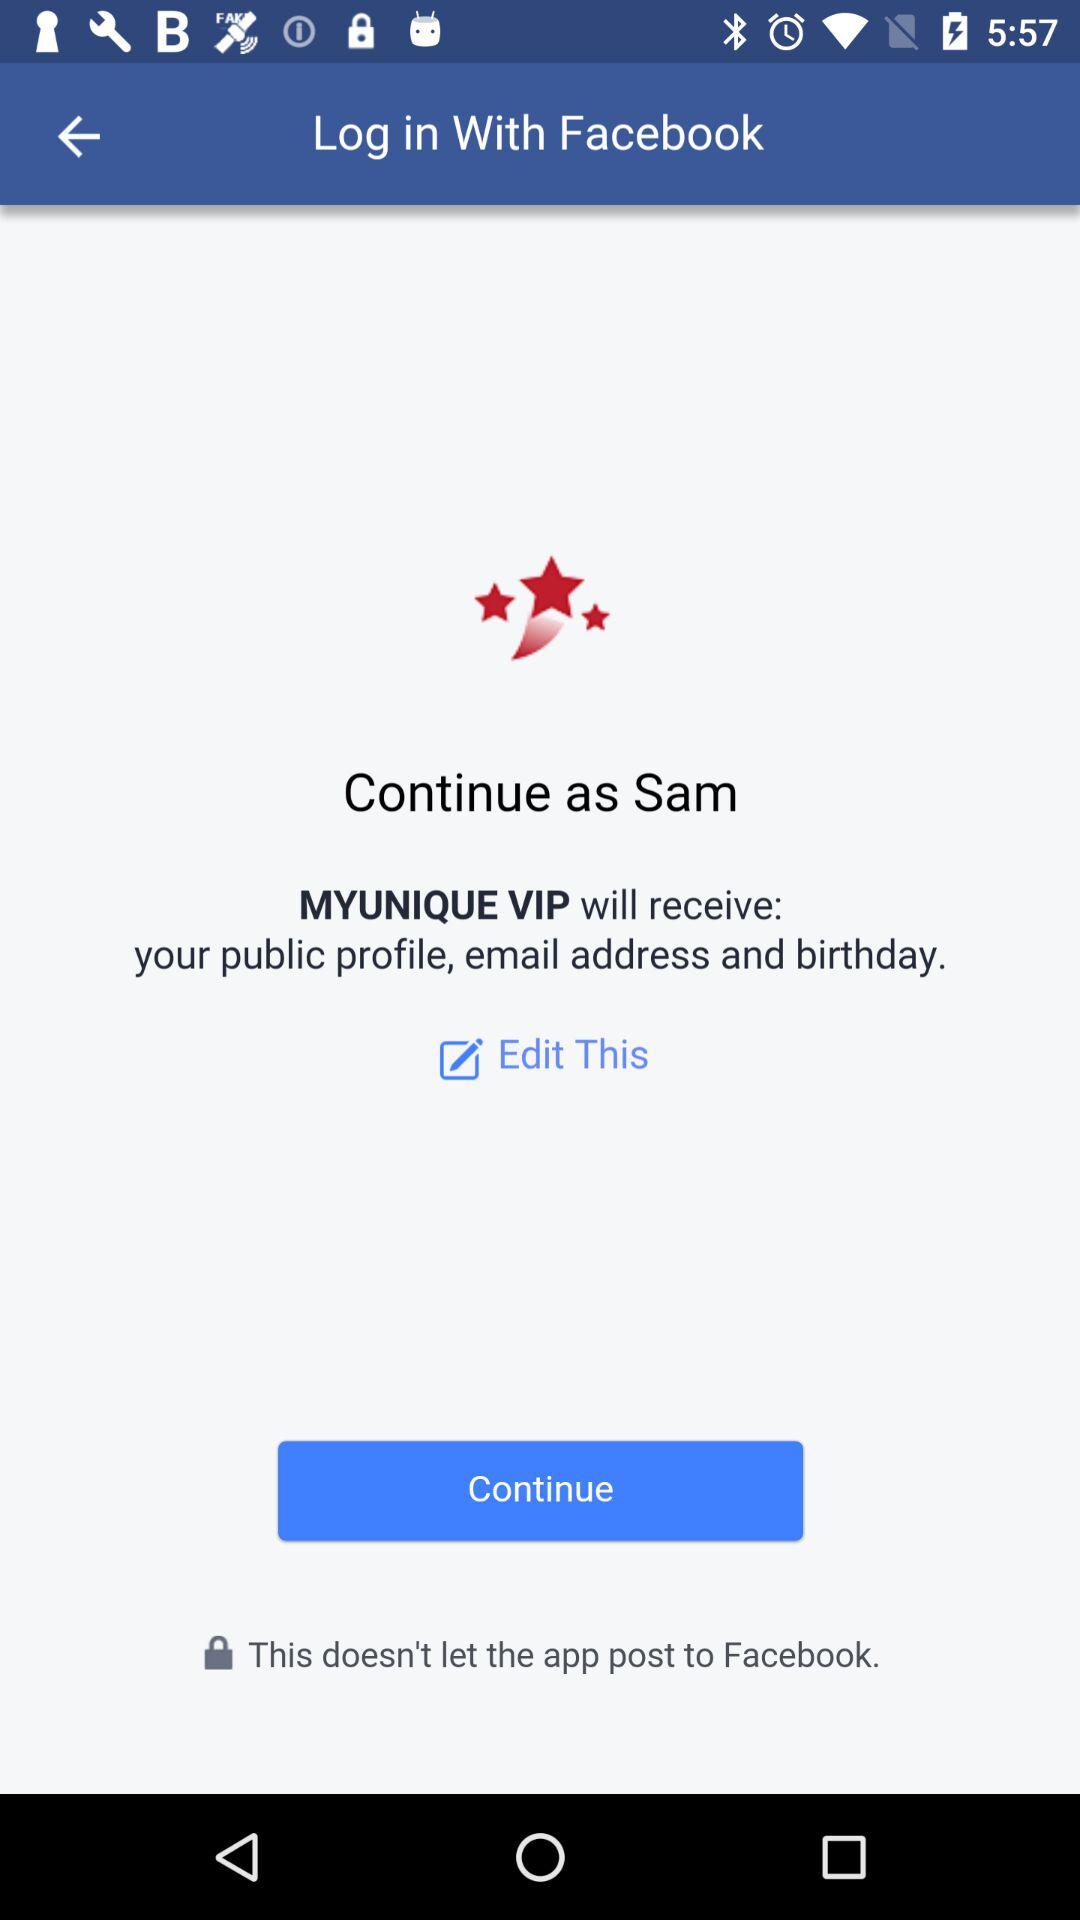What is Sam's last name?
When the provided information is insufficient, respond with <no answer>. <no answer> 